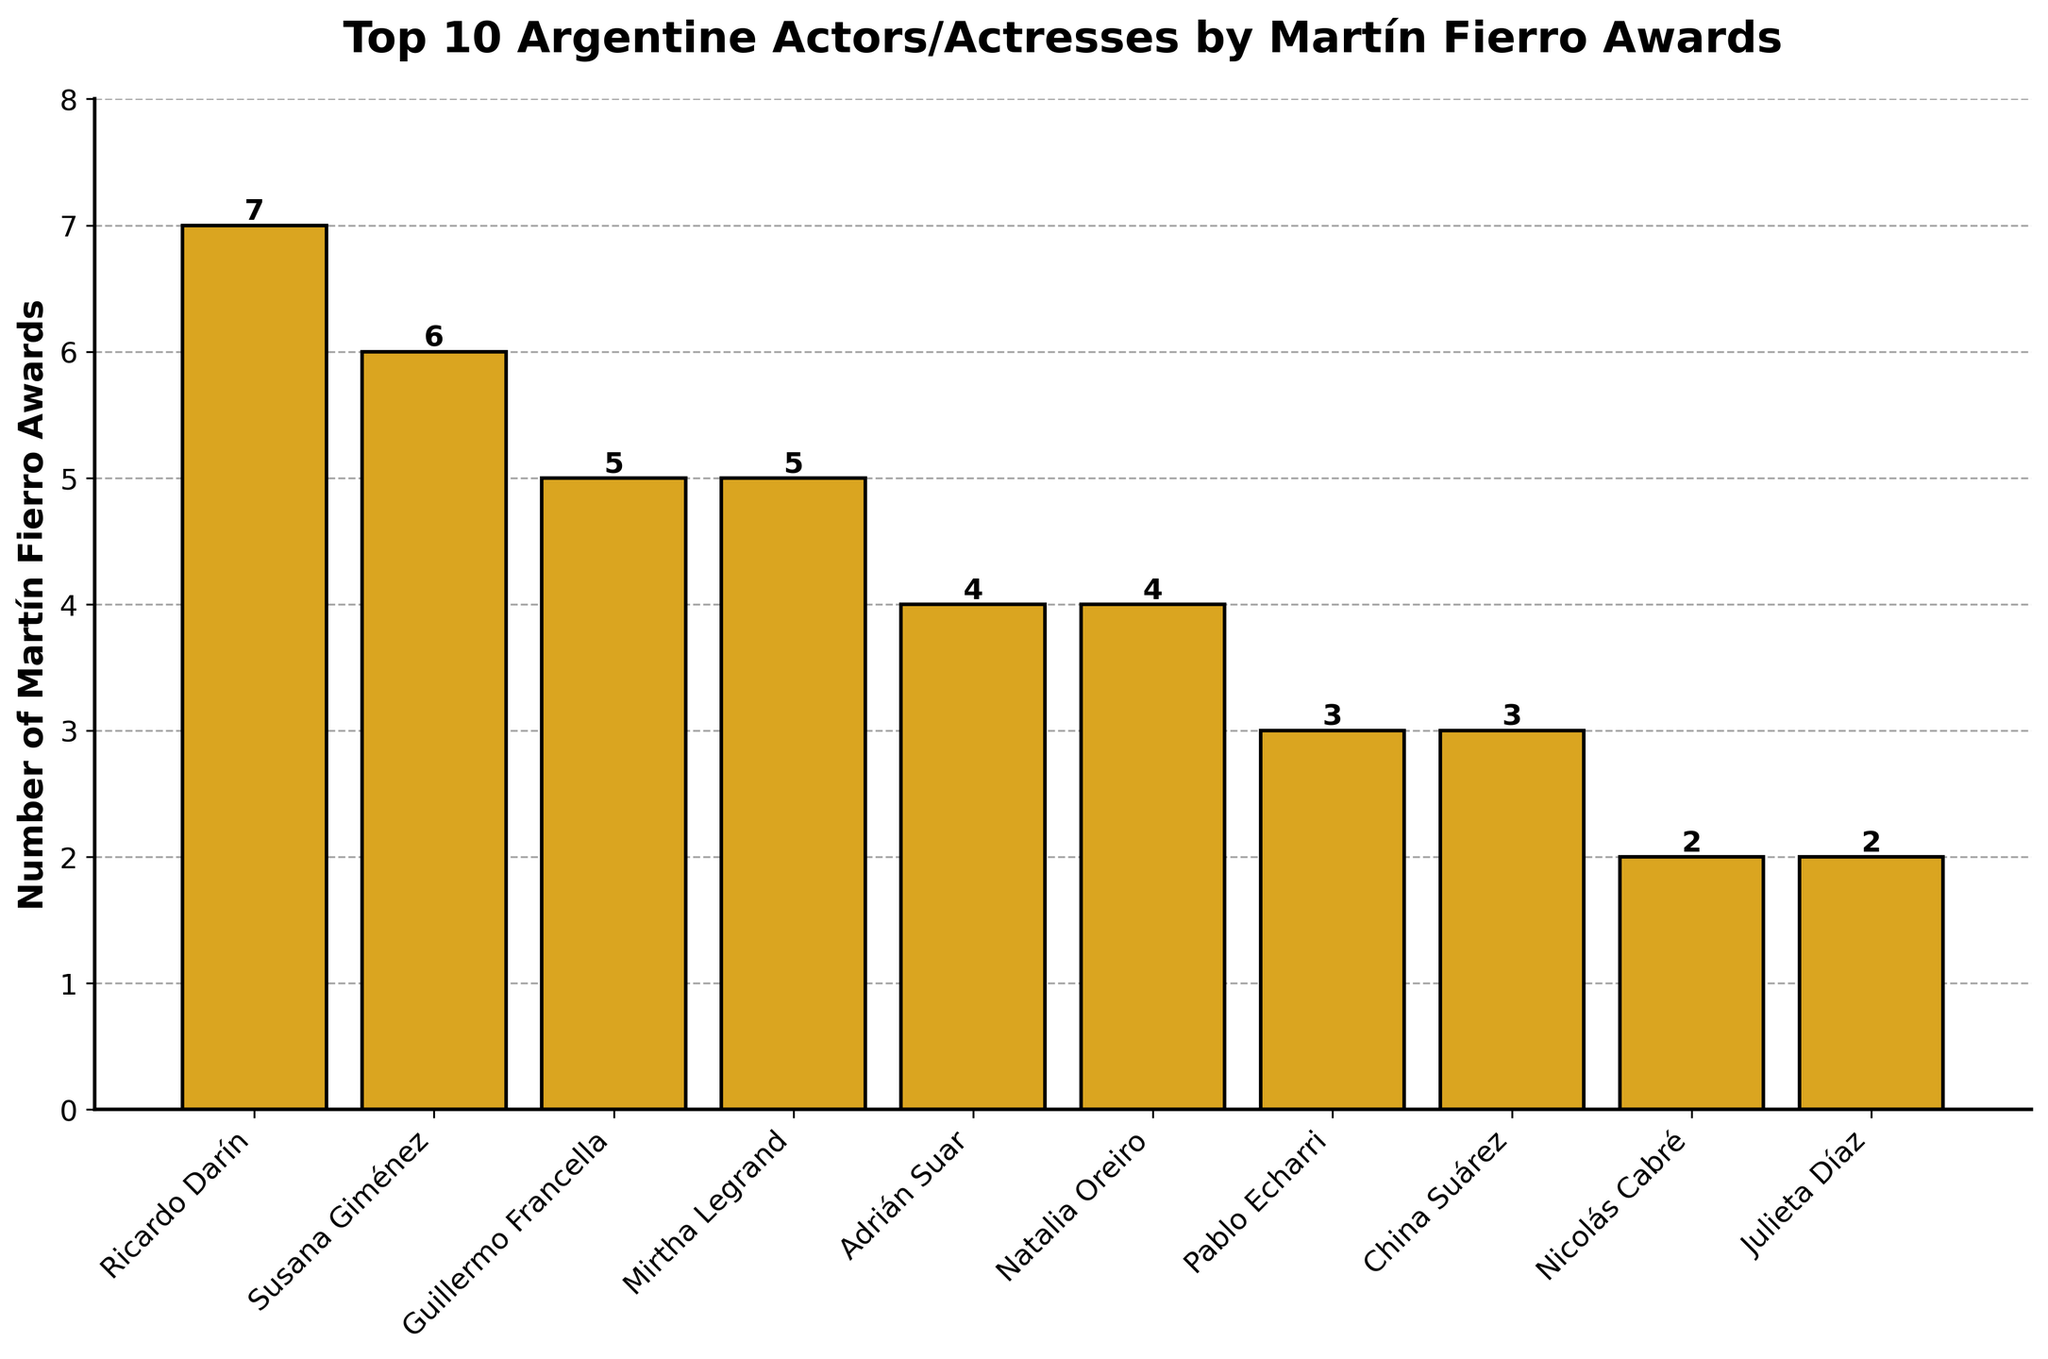Who has won the most Martín Fierro Awards? By looking at the height of the bars and identifying the one with the greatest value, you can determine the actor/actress with the most awards. The tallest bar is for Ricardo Darín, who has won 7 awards.
Answer: Ricardo Darín Which two actors/actresses have won the same number of Martín Fierro Awards at the top of the chart? By examining the heights and corresponding counts of the bars, you can see that Guillermo Francella and Mirtha Legrand both have bars of equal height, each representing 5 awards.
Answer: Guillermo Francella and Mirtha Legrand What is the total number of Martín Fierro Awards won by the top 3 actors/actresses combined? Sum the number of awards for the top 3 actors/actresses based on their bar heights: Ricardo Darín (7), Susana Giménez (6), and Guillermo Francella (5). The total is 7 + 6 + 5 = 18.
Answer: 18 How many actors/actresses have won 3 or more Martín Fierro Awards? Count the numbers represented on the vertical axis that are 3 or higher. These correspond to Ricardo Darín, Susana Giménez, Guillermo Francella, Mirtha Legrand, Adrián Suar, Natalia Oreiro, Pablo Echarri, and China Suárez. A total of 8 actors/actresses have won 3 or more awards.
Answer: 8 Who has won fewer Martín Fierro Awards: Nicolás Cabré or Julieta Díaz? By comparing the heights of the bars for Nicolás Cabré and Julieta Díaz, you can see that both have bars of equal height, each representing 2 awards.
Answer: They have won the same Which actor/actress has won exactly 4 Martín Fierro Awards? Look at the height of the bars and see the numerical labels that correspond to 4 awards, which are represented by Adrián Suar and Natalia Oreiro.
Answer: Adrián Suar and Natalia Oreiro How many more Martín Fierro Awards has Ricardo Darín won compared to Nicolás Cabré? Determine the number of awards Ricardo Darín has won (7) and subtract the number of awards won by Nicolás Cabré (2). The difference is 7 - 2 = 5.
Answer: 5 What is the average number of Martín Fierro Awards won by the top 10 actors/actresses? Sum the total number of awards: 7 + 6 + 5 + 5 + 4 + 4 + 3 + 3 + 2 + 2 = 41. Divide this by the number of actors/actresses (10). The average is 41 / 10 = 4.1.
Answer: 4.1 What is the combined number of awards for the actors/actresses who have won exactly 3 awards? Identify the actors with 3 awards: Pablo Echarri and China Suárez. Sum their awards: 3 + 3 = 6.
Answer: 6 Which actor/actress has won the second-highest number of Martín Fierro Awards and how many? Susana Giménez has won the second-highest number of Martín Fierro Awards, based on the second tallest bar, which shows she has won 6 awards.
Answer: Susana Giménez, 6 